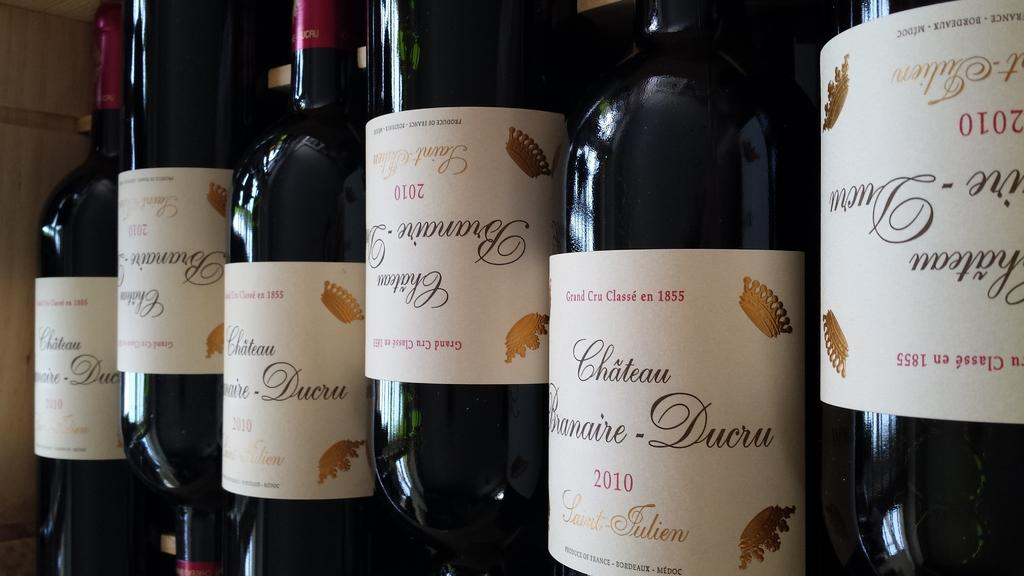<image>
Describe the image concisely. Several unopened black bottles of Chateau from 2010. 